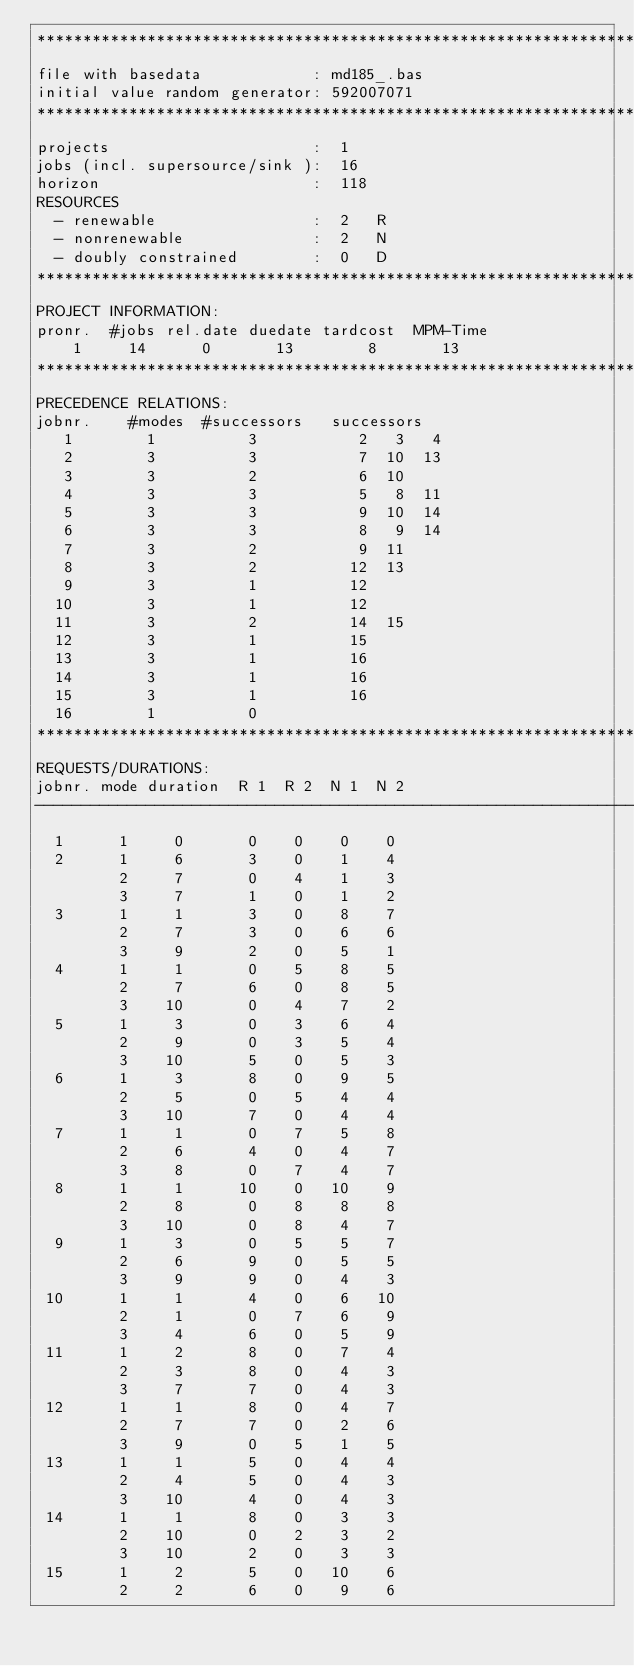<code> <loc_0><loc_0><loc_500><loc_500><_ObjectiveC_>************************************************************************
file with basedata            : md185_.bas
initial value random generator: 592007071
************************************************************************
projects                      :  1
jobs (incl. supersource/sink ):  16
horizon                       :  118
RESOURCES
  - renewable                 :  2   R
  - nonrenewable              :  2   N
  - doubly constrained        :  0   D
************************************************************************
PROJECT INFORMATION:
pronr.  #jobs rel.date duedate tardcost  MPM-Time
    1     14      0       13        8       13
************************************************************************
PRECEDENCE RELATIONS:
jobnr.    #modes  #successors   successors
   1        1          3           2   3   4
   2        3          3           7  10  13
   3        3          2           6  10
   4        3          3           5   8  11
   5        3          3           9  10  14
   6        3          3           8   9  14
   7        3          2           9  11
   8        3          2          12  13
   9        3          1          12
  10        3          1          12
  11        3          2          14  15
  12        3          1          15
  13        3          1          16
  14        3          1          16
  15        3          1          16
  16        1          0        
************************************************************************
REQUESTS/DURATIONS:
jobnr. mode duration  R 1  R 2  N 1  N 2
------------------------------------------------------------------------
  1      1     0       0    0    0    0
  2      1     6       3    0    1    4
         2     7       0    4    1    3
         3     7       1    0    1    2
  3      1     1       3    0    8    7
         2     7       3    0    6    6
         3     9       2    0    5    1
  4      1     1       0    5    8    5
         2     7       6    0    8    5
         3    10       0    4    7    2
  5      1     3       0    3    6    4
         2     9       0    3    5    4
         3    10       5    0    5    3
  6      1     3       8    0    9    5
         2     5       0    5    4    4
         3    10       7    0    4    4
  7      1     1       0    7    5    8
         2     6       4    0    4    7
         3     8       0    7    4    7
  8      1     1      10    0   10    9
         2     8       0    8    8    8
         3    10       0    8    4    7
  9      1     3       0    5    5    7
         2     6       9    0    5    5
         3     9       9    0    4    3
 10      1     1       4    0    6   10
         2     1       0    7    6    9
         3     4       6    0    5    9
 11      1     2       8    0    7    4
         2     3       8    0    4    3
         3     7       7    0    4    3
 12      1     1       8    0    4    7
         2     7       7    0    2    6
         3     9       0    5    1    5
 13      1     1       5    0    4    4
         2     4       5    0    4    3
         3    10       4    0    4    3
 14      1     1       8    0    3    3
         2    10       0    2    3    2
         3    10       2    0    3    3
 15      1     2       5    0   10    6
         2     2       6    0    9    6</code> 